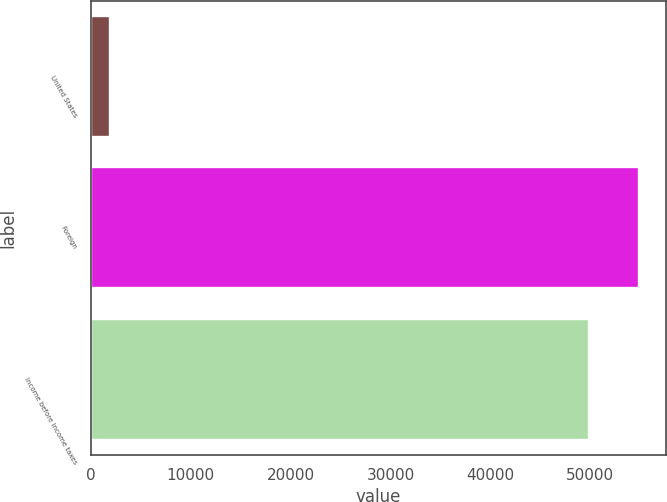Convert chart to OTSL. <chart><loc_0><loc_0><loc_500><loc_500><bar_chart><fcel>United States<fcel>Foreign<fcel>Income before income taxes<nl><fcel>1942<fcel>54868<fcel>49880<nl></chart> 